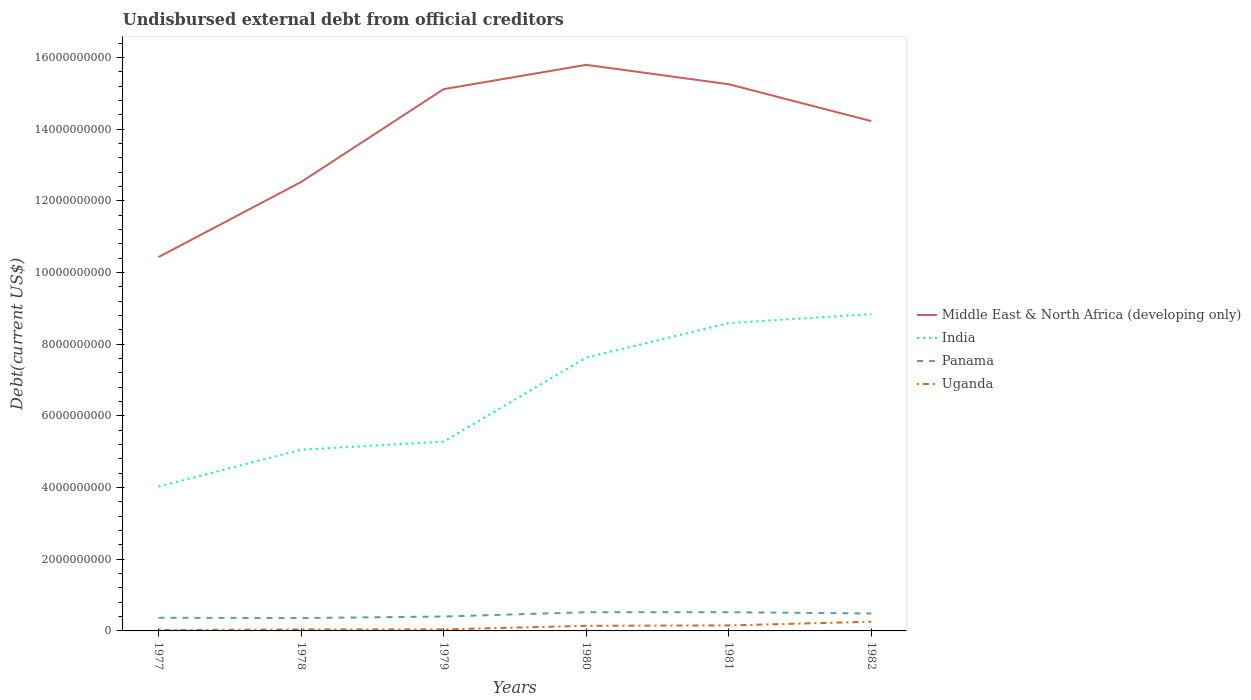Is the number of lines equal to the number of legend labels?
Keep it short and to the point. Yes. Across all years, what is the maximum total debt in Middle East & North Africa (developing only)?
Keep it short and to the point. 1.04e+1. What is the total total debt in Uganda in the graph?
Provide a succinct answer. -1.64e+07. What is the difference between the highest and the second highest total debt in India?
Make the answer very short. 4.81e+09. Is the total debt in Panama strictly greater than the total debt in Uganda over the years?
Provide a succinct answer. No. Does the graph contain any zero values?
Provide a succinct answer. No. Does the graph contain grids?
Your response must be concise. No. Where does the legend appear in the graph?
Ensure brevity in your answer.  Center right. What is the title of the graph?
Keep it short and to the point. Undisbursed external debt from official creditors. Does "Denmark" appear as one of the legend labels in the graph?
Offer a very short reply. No. What is the label or title of the Y-axis?
Keep it short and to the point. Debt(current US$). What is the Debt(current US$) of Middle East & North Africa (developing only) in 1977?
Keep it short and to the point. 1.04e+1. What is the Debt(current US$) in India in 1977?
Make the answer very short. 4.03e+09. What is the Debt(current US$) in Panama in 1977?
Your answer should be very brief. 3.67e+08. What is the Debt(current US$) in Uganda in 1977?
Keep it short and to the point. 2.43e+07. What is the Debt(current US$) in Middle East & North Africa (developing only) in 1978?
Your response must be concise. 1.25e+1. What is the Debt(current US$) of India in 1978?
Keep it short and to the point. 5.06e+09. What is the Debt(current US$) of Panama in 1978?
Make the answer very short. 3.59e+08. What is the Debt(current US$) in Uganda in 1978?
Provide a succinct answer. 4.07e+07. What is the Debt(current US$) of Middle East & North Africa (developing only) in 1979?
Offer a terse response. 1.51e+1. What is the Debt(current US$) in India in 1979?
Make the answer very short. 5.28e+09. What is the Debt(current US$) in Panama in 1979?
Keep it short and to the point. 4.02e+08. What is the Debt(current US$) of Uganda in 1979?
Offer a very short reply. 4.16e+07. What is the Debt(current US$) of Middle East & North Africa (developing only) in 1980?
Provide a short and direct response. 1.58e+1. What is the Debt(current US$) in India in 1980?
Ensure brevity in your answer.  7.63e+09. What is the Debt(current US$) in Panama in 1980?
Ensure brevity in your answer.  5.22e+08. What is the Debt(current US$) of Uganda in 1980?
Keep it short and to the point. 1.43e+08. What is the Debt(current US$) of Middle East & North Africa (developing only) in 1981?
Give a very brief answer. 1.53e+1. What is the Debt(current US$) in India in 1981?
Ensure brevity in your answer.  8.59e+09. What is the Debt(current US$) of Panama in 1981?
Provide a succinct answer. 5.22e+08. What is the Debt(current US$) in Uganda in 1981?
Offer a very short reply. 1.53e+08. What is the Debt(current US$) of Middle East & North Africa (developing only) in 1982?
Your answer should be very brief. 1.42e+1. What is the Debt(current US$) of India in 1982?
Keep it short and to the point. 8.84e+09. What is the Debt(current US$) in Panama in 1982?
Your response must be concise. 4.87e+08. What is the Debt(current US$) in Uganda in 1982?
Keep it short and to the point. 2.56e+08. Across all years, what is the maximum Debt(current US$) of Middle East & North Africa (developing only)?
Provide a short and direct response. 1.58e+1. Across all years, what is the maximum Debt(current US$) of India?
Offer a very short reply. 8.84e+09. Across all years, what is the maximum Debt(current US$) in Panama?
Keep it short and to the point. 5.22e+08. Across all years, what is the maximum Debt(current US$) in Uganda?
Your answer should be compact. 2.56e+08. Across all years, what is the minimum Debt(current US$) of Middle East & North Africa (developing only)?
Provide a succinct answer. 1.04e+1. Across all years, what is the minimum Debt(current US$) of India?
Provide a short and direct response. 4.03e+09. Across all years, what is the minimum Debt(current US$) in Panama?
Your answer should be very brief. 3.59e+08. Across all years, what is the minimum Debt(current US$) of Uganda?
Provide a succinct answer. 2.43e+07. What is the total Debt(current US$) of Middle East & North Africa (developing only) in the graph?
Your answer should be very brief. 8.34e+1. What is the total Debt(current US$) in India in the graph?
Provide a short and direct response. 3.94e+1. What is the total Debt(current US$) in Panama in the graph?
Ensure brevity in your answer.  2.66e+09. What is the total Debt(current US$) in Uganda in the graph?
Provide a short and direct response. 6.59e+08. What is the difference between the Debt(current US$) of Middle East & North Africa (developing only) in 1977 and that in 1978?
Provide a succinct answer. -2.10e+09. What is the difference between the Debt(current US$) in India in 1977 and that in 1978?
Provide a succinct answer. -1.03e+09. What is the difference between the Debt(current US$) of Panama in 1977 and that in 1978?
Offer a terse response. 8.48e+06. What is the difference between the Debt(current US$) of Uganda in 1977 and that in 1978?
Your answer should be compact. -1.64e+07. What is the difference between the Debt(current US$) in Middle East & North Africa (developing only) in 1977 and that in 1979?
Make the answer very short. -4.69e+09. What is the difference between the Debt(current US$) in India in 1977 and that in 1979?
Give a very brief answer. -1.25e+09. What is the difference between the Debt(current US$) in Panama in 1977 and that in 1979?
Your response must be concise. -3.46e+07. What is the difference between the Debt(current US$) in Uganda in 1977 and that in 1979?
Offer a terse response. -1.73e+07. What is the difference between the Debt(current US$) in Middle East & North Africa (developing only) in 1977 and that in 1980?
Provide a short and direct response. -5.37e+09. What is the difference between the Debt(current US$) of India in 1977 and that in 1980?
Provide a short and direct response. -3.60e+09. What is the difference between the Debt(current US$) in Panama in 1977 and that in 1980?
Make the answer very short. -1.54e+08. What is the difference between the Debt(current US$) of Uganda in 1977 and that in 1980?
Your response must be concise. -1.18e+08. What is the difference between the Debt(current US$) of Middle East & North Africa (developing only) in 1977 and that in 1981?
Ensure brevity in your answer.  -4.82e+09. What is the difference between the Debt(current US$) in India in 1977 and that in 1981?
Give a very brief answer. -4.56e+09. What is the difference between the Debt(current US$) in Panama in 1977 and that in 1981?
Your response must be concise. -1.55e+08. What is the difference between the Debt(current US$) of Uganda in 1977 and that in 1981?
Keep it short and to the point. -1.29e+08. What is the difference between the Debt(current US$) in Middle East & North Africa (developing only) in 1977 and that in 1982?
Ensure brevity in your answer.  -3.80e+09. What is the difference between the Debt(current US$) in India in 1977 and that in 1982?
Make the answer very short. -4.81e+09. What is the difference between the Debt(current US$) in Panama in 1977 and that in 1982?
Provide a succinct answer. -1.20e+08. What is the difference between the Debt(current US$) in Uganda in 1977 and that in 1982?
Give a very brief answer. -2.32e+08. What is the difference between the Debt(current US$) of Middle East & North Africa (developing only) in 1978 and that in 1979?
Offer a terse response. -2.59e+09. What is the difference between the Debt(current US$) in India in 1978 and that in 1979?
Give a very brief answer. -2.26e+08. What is the difference between the Debt(current US$) of Panama in 1978 and that in 1979?
Ensure brevity in your answer.  -4.30e+07. What is the difference between the Debt(current US$) of Uganda in 1978 and that in 1979?
Give a very brief answer. -9.00e+05. What is the difference between the Debt(current US$) of Middle East & North Africa (developing only) in 1978 and that in 1980?
Offer a terse response. -3.27e+09. What is the difference between the Debt(current US$) in India in 1978 and that in 1980?
Make the answer very short. -2.57e+09. What is the difference between the Debt(current US$) in Panama in 1978 and that in 1980?
Ensure brevity in your answer.  -1.63e+08. What is the difference between the Debt(current US$) of Uganda in 1978 and that in 1980?
Offer a terse response. -1.02e+08. What is the difference between the Debt(current US$) of Middle East & North Africa (developing only) in 1978 and that in 1981?
Provide a succinct answer. -2.73e+09. What is the difference between the Debt(current US$) of India in 1978 and that in 1981?
Make the answer very short. -3.53e+09. What is the difference between the Debt(current US$) of Panama in 1978 and that in 1981?
Provide a short and direct response. -1.63e+08. What is the difference between the Debt(current US$) in Uganda in 1978 and that in 1981?
Keep it short and to the point. -1.13e+08. What is the difference between the Debt(current US$) in Middle East & North Africa (developing only) in 1978 and that in 1982?
Your answer should be compact. -1.70e+09. What is the difference between the Debt(current US$) of India in 1978 and that in 1982?
Keep it short and to the point. -3.78e+09. What is the difference between the Debt(current US$) in Panama in 1978 and that in 1982?
Your answer should be very brief. -1.28e+08. What is the difference between the Debt(current US$) in Uganda in 1978 and that in 1982?
Offer a terse response. -2.16e+08. What is the difference between the Debt(current US$) of Middle East & North Africa (developing only) in 1979 and that in 1980?
Ensure brevity in your answer.  -6.79e+08. What is the difference between the Debt(current US$) in India in 1979 and that in 1980?
Your answer should be very brief. -2.35e+09. What is the difference between the Debt(current US$) of Panama in 1979 and that in 1980?
Provide a short and direct response. -1.20e+08. What is the difference between the Debt(current US$) of Uganda in 1979 and that in 1980?
Provide a succinct answer. -1.01e+08. What is the difference between the Debt(current US$) in Middle East & North Africa (developing only) in 1979 and that in 1981?
Make the answer very short. -1.38e+08. What is the difference between the Debt(current US$) in India in 1979 and that in 1981?
Offer a terse response. -3.31e+09. What is the difference between the Debt(current US$) of Panama in 1979 and that in 1981?
Give a very brief answer. -1.20e+08. What is the difference between the Debt(current US$) in Uganda in 1979 and that in 1981?
Give a very brief answer. -1.12e+08. What is the difference between the Debt(current US$) in Middle East & North Africa (developing only) in 1979 and that in 1982?
Your response must be concise. 8.91e+08. What is the difference between the Debt(current US$) of India in 1979 and that in 1982?
Your answer should be compact. -3.56e+09. What is the difference between the Debt(current US$) of Panama in 1979 and that in 1982?
Give a very brief answer. -8.52e+07. What is the difference between the Debt(current US$) in Uganda in 1979 and that in 1982?
Provide a succinct answer. -2.15e+08. What is the difference between the Debt(current US$) in Middle East & North Africa (developing only) in 1980 and that in 1981?
Your answer should be compact. 5.41e+08. What is the difference between the Debt(current US$) of India in 1980 and that in 1981?
Ensure brevity in your answer.  -9.64e+08. What is the difference between the Debt(current US$) in Panama in 1980 and that in 1981?
Offer a terse response. -1.86e+05. What is the difference between the Debt(current US$) in Uganda in 1980 and that in 1981?
Your response must be concise. -1.08e+07. What is the difference between the Debt(current US$) of Middle East & North Africa (developing only) in 1980 and that in 1982?
Your answer should be compact. 1.57e+09. What is the difference between the Debt(current US$) of India in 1980 and that in 1982?
Ensure brevity in your answer.  -1.21e+09. What is the difference between the Debt(current US$) in Panama in 1980 and that in 1982?
Offer a terse response. 3.46e+07. What is the difference between the Debt(current US$) of Uganda in 1980 and that in 1982?
Offer a terse response. -1.14e+08. What is the difference between the Debt(current US$) in Middle East & North Africa (developing only) in 1981 and that in 1982?
Your answer should be very brief. 1.03e+09. What is the difference between the Debt(current US$) in India in 1981 and that in 1982?
Give a very brief answer. -2.50e+08. What is the difference between the Debt(current US$) of Panama in 1981 and that in 1982?
Make the answer very short. 3.48e+07. What is the difference between the Debt(current US$) of Uganda in 1981 and that in 1982?
Keep it short and to the point. -1.03e+08. What is the difference between the Debt(current US$) in Middle East & North Africa (developing only) in 1977 and the Debt(current US$) in India in 1978?
Your answer should be compact. 5.38e+09. What is the difference between the Debt(current US$) of Middle East & North Africa (developing only) in 1977 and the Debt(current US$) of Panama in 1978?
Provide a succinct answer. 1.01e+1. What is the difference between the Debt(current US$) of Middle East & North Africa (developing only) in 1977 and the Debt(current US$) of Uganda in 1978?
Your answer should be compact. 1.04e+1. What is the difference between the Debt(current US$) of India in 1977 and the Debt(current US$) of Panama in 1978?
Your answer should be very brief. 3.67e+09. What is the difference between the Debt(current US$) in India in 1977 and the Debt(current US$) in Uganda in 1978?
Offer a terse response. 3.99e+09. What is the difference between the Debt(current US$) in Panama in 1977 and the Debt(current US$) in Uganda in 1978?
Offer a very short reply. 3.27e+08. What is the difference between the Debt(current US$) in Middle East & North Africa (developing only) in 1977 and the Debt(current US$) in India in 1979?
Provide a succinct answer. 5.15e+09. What is the difference between the Debt(current US$) in Middle East & North Africa (developing only) in 1977 and the Debt(current US$) in Panama in 1979?
Make the answer very short. 1.00e+1. What is the difference between the Debt(current US$) of Middle East & North Africa (developing only) in 1977 and the Debt(current US$) of Uganda in 1979?
Offer a very short reply. 1.04e+1. What is the difference between the Debt(current US$) in India in 1977 and the Debt(current US$) in Panama in 1979?
Your response must be concise. 3.63e+09. What is the difference between the Debt(current US$) in India in 1977 and the Debt(current US$) in Uganda in 1979?
Offer a terse response. 3.99e+09. What is the difference between the Debt(current US$) of Panama in 1977 and the Debt(current US$) of Uganda in 1979?
Offer a very short reply. 3.26e+08. What is the difference between the Debt(current US$) of Middle East & North Africa (developing only) in 1977 and the Debt(current US$) of India in 1980?
Offer a very short reply. 2.80e+09. What is the difference between the Debt(current US$) in Middle East & North Africa (developing only) in 1977 and the Debt(current US$) in Panama in 1980?
Give a very brief answer. 9.91e+09. What is the difference between the Debt(current US$) of Middle East & North Africa (developing only) in 1977 and the Debt(current US$) of Uganda in 1980?
Make the answer very short. 1.03e+1. What is the difference between the Debt(current US$) in India in 1977 and the Debt(current US$) in Panama in 1980?
Give a very brief answer. 3.51e+09. What is the difference between the Debt(current US$) of India in 1977 and the Debt(current US$) of Uganda in 1980?
Ensure brevity in your answer.  3.89e+09. What is the difference between the Debt(current US$) of Panama in 1977 and the Debt(current US$) of Uganda in 1980?
Make the answer very short. 2.25e+08. What is the difference between the Debt(current US$) of Middle East & North Africa (developing only) in 1977 and the Debt(current US$) of India in 1981?
Offer a terse response. 1.84e+09. What is the difference between the Debt(current US$) of Middle East & North Africa (developing only) in 1977 and the Debt(current US$) of Panama in 1981?
Your response must be concise. 9.91e+09. What is the difference between the Debt(current US$) of Middle East & North Africa (developing only) in 1977 and the Debt(current US$) of Uganda in 1981?
Provide a short and direct response. 1.03e+1. What is the difference between the Debt(current US$) in India in 1977 and the Debt(current US$) in Panama in 1981?
Ensure brevity in your answer.  3.51e+09. What is the difference between the Debt(current US$) of India in 1977 and the Debt(current US$) of Uganda in 1981?
Provide a short and direct response. 3.88e+09. What is the difference between the Debt(current US$) of Panama in 1977 and the Debt(current US$) of Uganda in 1981?
Keep it short and to the point. 2.14e+08. What is the difference between the Debt(current US$) in Middle East & North Africa (developing only) in 1977 and the Debt(current US$) in India in 1982?
Keep it short and to the point. 1.59e+09. What is the difference between the Debt(current US$) of Middle East & North Africa (developing only) in 1977 and the Debt(current US$) of Panama in 1982?
Provide a succinct answer. 9.95e+09. What is the difference between the Debt(current US$) of Middle East & North Africa (developing only) in 1977 and the Debt(current US$) of Uganda in 1982?
Your answer should be very brief. 1.02e+1. What is the difference between the Debt(current US$) in India in 1977 and the Debt(current US$) in Panama in 1982?
Ensure brevity in your answer.  3.54e+09. What is the difference between the Debt(current US$) of India in 1977 and the Debt(current US$) of Uganda in 1982?
Offer a very short reply. 3.77e+09. What is the difference between the Debt(current US$) in Panama in 1977 and the Debt(current US$) in Uganda in 1982?
Provide a succinct answer. 1.11e+08. What is the difference between the Debt(current US$) in Middle East & North Africa (developing only) in 1978 and the Debt(current US$) in India in 1979?
Provide a short and direct response. 7.25e+09. What is the difference between the Debt(current US$) of Middle East & North Africa (developing only) in 1978 and the Debt(current US$) of Panama in 1979?
Give a very brief answer. 1.21e+1. What is the difference between the Debt(current US$) of Middle East & North Africa (developing only) in 1978 and the Debt(current US$) of Uganda in 1979?
Your answer should be very brief. 1.25e+1. What is the difference between the Debt(current US$) in India in 1978 and the Debt(current US$) in Panama in 1979?
Provide a succinct answer. 4.66e+09. What is the difference between the Debt(current US$) in India in 1978 and the Debt(current US$) in Uganda in 1979?
Offer a terse response. 5.02e+09. What is the difference between the Debt(current US$) in Panama in 1978 and the Debt(current US$) in Uganda in 1979?
Make the answer very short. 3.17e+08. What is the difference between the Debt(current US$) in Middle East & North Africa (developing only) in 1978 and the Debt(current US$) in India in 1980?
Offer a very short reply. 4.90e+09. What is the difference between the Debt(current US$) in Middle East & North Africa (developing only) in 1978 and the Debt(current US$) in Panama in 1980?
Ensure brevity in your answer.  1.20e+1. What is the difference between the Debt(current US$) in Middle East & North Africa (developing only) in 1978 and the Debt(current US$) in Uganda in 1980?
Your answer should be compact. 1.24e+1. What is the difference between the Debt(current US$) in India in 1978 and the Debt(current US$) in Panama in 1980?
Your answer should be very brief. 4.54e+09. What is the difference between the Debt(current US$) in India in 1978 and the Debt(current US$) in Uganda in 1980?
Keep it short and to the point. 4.91e+09. What is the difference between the Debt(current US$) in Panama in 1978 and the Debt(current US$) in Uganda in 1980?
Offer a terse response. 2.16e+08. What is the difference between the Debt(current US$) of Middle East & North Africa (developing only) in 1978 and the Debt(current US$) of India in 1981?
Offer a very short reply. 3.94e+09. What is the difference between the Debt(current US$) in Middle East & North Africa (developing only) in 1978 and the Debt(current US$) in Panama in 1981?
Provide a short and direct response. 1.20e+1. What is the difference between the Debt(current US$) in Middle East & North Africa (developing only) in 1978 and the Debt(current US$) in Uganda in 1981?
Keep it short and to the point. 1.24e+1. What is the difference between the Debt(current US$) of India in 1978 and the Debt(current US$) of Panama in 1981?
Your answer should be compact. 4.54e+09. What is the difference between the Debt(current US$) of India in 1978 and the Debt(current US$) of Uganda in 1981?
Give a very brief answer. 4.90e+09. What is the difference between the Debt(current US$) of Panama in 1978 and the Debt(current US$) of Uganda in 1981?
Your answer should be very brief. 2.05e+08. What is the difference between the Debt(current US$) in Middle East & North Africa (developing only) in 1978 and the Debt(current US$) in India in 1982?
Offer a terse response. 3.69e+09. What is the difference between the Debt(current US$) in Middle East & North Africa (developing only) in 1978 and the Debt(current US$) in Panama in 1982?
Offer a very short reply. 1.20e+1. What is the difference between the Debt(current US$) of Middle East & North Africa (developing only) in 1978 and the Debt(current US$) of Uganda in 1982?
Keep it short and to the point. 1.23e+1. What is the difference between the Debt(current US$) of India in 1978 and the Debt(current US$) of Panama in 1982?
Your answer should be very brief. 4.57e+09. What is the difference between the Debt(current US$) in India in 1978 and the Debt(current US$) in Uganda in 1982?
Give a very brief answer. 4.80e+09. What is the difference between the Debt(current US$) in Panama in 1978 and the Debt(current US$) in Uganda in 1982?
Provide a succinct answer. 1.02e+08. What is the difference between the Debt(current US$) in Middle East & North Africa (developing only) in 1979 and the Debt(current US$) in India in 1980?
Keep it short and to the point. 7.49e+09. What is the difference between the Debt(current US$) of Middle East & North Africa (developing only) in 1979 and the Debt(current US$) of Panama in 1980?
Your answer should be very brief. 1.46e+1. What is the difference between the Debt(current US$) in Middle East & North Africa (developing only) in 1979 and the Debt(current US$) in Uganda in 1980?
Keep it short and to the point. 1.50e+1. What is the difference between the Debt(current US$) of India in 1979 and the Debt(current US$) of Panama in 1980?
Give a very brief answer. 4.76e+09. What is the difference between the Debt(current US$) of India in 1979 and the Debt(current US$) of Uganda in 1980?
Make the answer very short. 5.14e+09. What is the difference between the Debt(current US$) in Panama in 1979 and the Debt(current US$) in Uganda in 1980?
Your answer should be very brief. 2.59e+08. What is the difference between the Debt(current US$) of Middle East & North Africa (developing only) in 1979 and the Debt(current US$) of India in 1981?
Your response must be concise. 6.53e+09. What is the difference between the Debt(current US$) of Middle East & North Africa (developing only) in 1979 and the Debt(current US$) of Panama in 1981?
Your answer should be compact. 1.46e+1. What is the difference between the Debt(current US$) of Middle East & North Africa (developing only) in 1979 and the Debt(current US$) of Uganda in 1981?
Your answer should be very brief. 1.50e+1. What is the difference between the Debt(current US$) in India in 1979 and the Debt(current US$) in Panama in 1981?
Give a very brief answer. 4.76e+09. What is the difference between the Debt(current US$) in India in 1979 and the Debt(current US$) in Uganda in 1981?
Offer a very short reply. 5.13e+09. What is the difference between the Debt(current US$) in Panama in 1979 and the Debt(current US$) in Uganda in 1981?
Offer a very short reply. 2.48e+08. What is the difference between the Debt(current US$) of Middle East & North Africa (developing only) in 1979 and the Debt(current US$) of India in 1982?
Offer a very short reply. 6.28e+09. What is the difference between the Debt(current US$) of Middle East & North Africa (developing only) in 1979 and the Debt(current US$) of Panama in 1982?
Ensure brevity in your answer.  1.46e+1. What is the difference between the Debt(current US$) of Middle East & North Africa (developing only) in 1979 and the Debt(current US$) of Uganda in 1982?
Your response must be concise. 1.49e+1. What is the difference between the Debt(current US$) of India in 1979 and the Debt(current US$) of Panama in 1982?
Offer a terse response. 4.80e+09. What is the difference between the Debt(current US$) in India in 1979 and the Debt(current US$) in Uganda in 1982?
Provide a succinct answer. 5.03e+09. What is the difference between the Debt(current US$) in Panama in 1979 and the Debt(current US$) in Uganda in 1982?
Provide a short and direct response. 1.45e+08. What is the difference between the Debt(current US$) in Middle East & North Africa (developing only) in 1980 and the Debt(current US$) in India in 1981?
Ensure brevity in your answer.  7.21e+09. What is the difference between the Debt(current US$) in Middle East & North Africa (developing only) in 1980 and the Debt(current US$) in Panama in 1981?
Provide a short and direct response. 1.53e+1. What is the difference between the Debt(current US$) in Middle East & North Africa (developing only) in 1980 and the Debt(current US$) in Uganda in 1981?
Offer a very short reply. 1.56e+1. What is the difference between the Debt(current US$) of India in 1980 and the Debt(current US$) of Panama in 1981?
Provide a short and direct response. 7.11e+09. What is the difference between the Debt(current US$) of India in 1980 and the Debt(current US$) of Uganda in 1981?
Give a very brief answer. 7.48e+09. What is the difference between the Debt(current US$) of Panama in 1980 and the Debt(current US$) of Uganda in 1981?
Give a very brief answer. 3.68e+08. What is the difference between the Debt(current US$) in Middle East & North Africa (developing only) in 1980 and the Debt(current US$) in India in 1982?
Offer a very short reply. 6.96e+09. What is the difference between the Debt(current US$) of Middle East & North Africa (developing only) in 1980 and the Debt(current US$) of Panama in 1982?
Your answer should be compact. 1.53e+1. What is the difference between the Debt(current US$) in Middle East & North Africa (developing only) in 1980 and the Debt(current US$) in Uganda in 1982?
Offer a very short reply. 1.55e+1. What is the difference between the Debt(current US$) in India in 1980 and the Debt(current US$) in Panama in 1982?
Provide a succinct answer. 7.14e+09. What is the difference between the Debt(current US$) in India in 1980 and the Debt(current US$) in Uganda in 1982?
Keep it short and to the point. 7.37e+09. What is the difference between the Debt(current US$) in Panama in 1980 and the Debt(current US$) in Uganda in 1982?
Provide a short and direct response. 2.65e+08. What is the difference between the Debt(current US$) in Middle East & North Africa (developing only) in 1981 and the Debt(current US$) in India in 1982?
Your response must be concise. 6.42e+09. What is the difference between the Debt(current US$) in Middle East & North Africa (developing only) in 1981 and the Debt(current US$) in Panama in 1982?
Make the answer very short. 1.48e+1. What is the difference between the Debt(current US$) of Middle East & North Africa (developing only) in 1981 and the Debt(current US$) of Uganda in 1982?
Offer a very short reply. 1.50e+1. What is the difference between the Debt(current US$) of India in 1981 and the Debt(current US$) of Panama in 1982?
Offer a very short reply. 8.11e+09. What is the difference between the Debt(current US$) of India in 1981 and the Debt(current US$) of Uganda in 1982?
Offer a very short reply. 8.34e+09. What is the difference between the Debt(current US$) in Panama in 1981 and the Debt(current US$) in Uganda in 1982?
Provide a succinct answer. 2.65e+08. What is the average Debt(current US$) in Middle East & North Africa (developing only) per year?
Your answer should be very brief. 1.39e+1. What is the average Debt(current US$) in India per year?
Ensure brevity in your answer.  6.57e+09. What is the average Debt(current US$) in Panama per year?
Provide a short and direct response. 4.43e+08. What is the average Debt(current US$) in Uganda per year?
Ensure brevity in your answer.  1.10e+08. In the year 1977, what is the difference between the Debt(current US$) of Middle East & North Africa (developing only) and Debt(current US$) of India?
Provide a succinct answer. 6.40e+09. In the year 1977, what is the difference between the Debt(current US$) in Middle East & North Africa (developing only) and Debt(current US$) in Panama?
Provide a succinct answer. 1.01e+1. In the year 1977, what is the difference between the Debt(current US$) in Middle East & North Africa (developing only) and Debt(current US$) in Uganda?
Ensure brevity in your answer.  1.04e+1. In the year 1977, what is the difference between the Debt(current US$) in India and Debt(current US$) in Panama?
Offer a terse response. 3.66e+09. In the year 1977, what is the difference between the Debt(current US$) of India and Debt(current US$) of Uganda?
Your answer should be compact. 4.00e+09. In the year 1977, what is the difference between the Debt(current US$) in Panama and Debt(current US$) in Uganda?
Provide a short and direct response. 3.43e+08. In the year 1978, what is the difference between the Debt(current US$) of Middle East & North Africa (developing only) and Debt(current US$) of India?
Your answer should be compact. 7.47e+09. In the year 1978, what is the difference between the Debt(current US$) of Middle East & North Africa (developing only) and Debt(current US$) of Panama?
Provide a succinct answer. 1.22e+1. In the year 1978, what is the difference between the Debt(current US$) of Middle East & North Africa (developing only) and Debt(current US$) of Uganda?
Your answer should be very brief. 1.25e+1. In the year 1978, what is the difference between the Debt(current US$) of India and Debt(current US$) of Panama?
Offer a very short reply. 4.70e+09. In the year 1978, what is the difference between the Debt(current US$) in India and Debt(current US$) in Uganda?
Your answer should be compact. 5.02e+09. In the year 1978, what is the difference between the Debt(current US$) in Panama and Debt(current US$) in Uganda?
Make the answer very short. 3.18e+08. In the year 1979, what is the difference between the Debt(current US$) of Middle East & North Africa (developing only) and Debt(current US$) of India?
Make the answer very short. 9.84e+09. In the year 1979, what is the difference between the Debt(current US$) in Middle East & North Africa (developing only) and Debt(current US$) in Panama?
Your answer should be compact. 1.47e+1. In the year 1979, what is the difference between the Debt(current US$) in Middle East & North Africa (developing only) and Debt(current US$) in Uganda?
Provide a short and direct response. 1.51e+1. In the year 1979, what is the difference between the Debt(current US$) in India and Debt(current US$) in Panama?
Offer a terse response. 4.88e+09. In the year 1979, what is the difference between the Debt(current US$) in India and Debt(current US$) in Uganda?
Your answer should be very brief. 5.24e+09. In the year 1979, what is the difference between the Debt(current US$) of Panama and Debt(current US$) of Uganda?
Your answer should be very brief. 3.60e+08. In the year 1980, what is the difference between the Debt(current US$) in Middle East & North Africa (developing only) and Debt(current US$) in India?
Your response must be concise. 8.17e+09. In the year 1980, what is the difference between the Debt(current US$) in Middle East & North Africa (developing only) and Debt(current US$) in Panama?
Provide a short and direct response. 1.53e+1. In the year 1980, what is the difference between the Debt(current US$) of Middle East & North Africa (developing only) and Debt(current US$) of Uganda?
Offer a terse response. 1.57e+1. In the year 1980, what is the difference between the Debt(current US$) in India and Debt(current US$) in Panama?
Your answer should be compact. 7.11e+09. In the year 1980, what is the difference between the Debt(current US$) of India and Debt(current US$) of Uganda?
Keep it short and to the point. 7.49e+09. In the year 1980, what is the difference between the Debt(current US$) of Panama and Debt(current US$) of Uganda?
Give a very brief answer. 3.79e+08. In the year 1981, what is the difference between the Debt(current US$) in Middle East & North Africa (developing only) and Debt(current US$) in India?
Give a very brief answer. 6.67e+09. In the year 1981, what is the difference between the Debt(current US$) in Middle East & North Africa (developing only) and Debt(current US$) in Panama?
Make the answer very short. 1.47e+1. In the year 1981, what is the difference between the Debt(current US$) in Middle East & North Africa (developing only) and Debt(current US$) in Uganda?
Offer a very short reply. 1.51e+1. In the year 1981, what is the difference between the Debt(current US$) in India and Debt(current US$) in Panama?
Give a very brief answer. 8.07e+09. In the year 1981, what is the difference between the Debt(current US$) of India and Debt(current US$) of Uganda?
Your answer should be very brief. 8.44e+09. In the year 1981, what is the difference between the Debt(current US$) of Panama and Debt(current US$) of Uganda?
Provide a succinct answer. 3.68e+08. In the year 1982, what is the difference between the Debt(current US$) of Middle East & North Africa (developing only) and Debt(current US$) of India?
Keep it short and to the point. 5.39e+09. In the year 1982, what is the difference between the Debt(current US$) in Middle East & North Africa (developing only) and Debt(current US$) in Panama?
Your response must be concise. 1.37e+1. In the year 1982, what is the difference between the Debt(current US$) of Middle East & North Africa (developing only) and Debt(current US$) of Uganda?
Give a very brief answer. 1.40e+1. In the year 1982, what is the difference between the Debt(current US$) of India and Debt(current US$) of Panama?
Your answer should be compact. 8.36e+09. In the year 1982, what is the difference between the Debt(current US$) of India and Debt(current US$) of Uganda?
Offer a very short reply. 8.59e+09. In the year 1982, what is the difference between the Debt(current US$) of Panama and Debt(current US$) of Uganda?
Your answer should be very brief. 2.31e+08. What is the ratio of the Debt(current US$) in Middle East & North Africa (developing only) in 1977 to that in 1978?
Offer a terse response. 0.83. What is the ratio of the Debt(current US$) of India in 1977 to that in 1978?
Your answer should be very brief. 0.8. What is the ratio of the Debt(current US$) of Panama in 1977 to that in 1978?
Provide a succinct answer. 1.02. What is the ratio of the Debt(current US$) of Uganda in 1977 to that in 1978?
Provide a short and direct response. 0.6. What is the ratio of the Debt(current US$) in Middle East & North Africa (developing only) in 1977 to that in 1979?
Give a very brief answer. 0.69. What is the ratio of the Debt(current US$) of India in 1977 to that in 1979?
Give a very brief answer. 0.76. What is the ratio of the Debt(current US$) of Panama in 1977 to that in 1979?
Make the answer very short. 0.91. What is the ratio of the Debt(current US$) in Uganda in 1977 to that in 1979?
Offer a terse response. 0.58. What is the ratio of the Debt(current US$) in Middle East & North Africa (developing only) in 1977 to that in 1980?
Your response must be concise. 0.66. What is the ratio of the Debt(current US$) in India in 1977 to that in 1980?
Keep it short and to the point. 0.53. What is the ratio of the Debt(current US$) in Panama in 1977 to that in 1980?
Give a very brief answer. 0.7. What is the ratio of the Debt(current US$) of Uganda in 1977 to that in 1980?
Provide a short and direct response. 0.17. What is the ratio of the Debt(current US$) of Middle East & North Africa (developing only) in 1977 to that in 1981?
Provide a short and direct response. 0.68. What is the ratio of the Debt(current US$) of India in 1977 to that in 1981?
Keep it short and to the point. 0.47. What is the ratio of the Debt(current US$) in Panama in 1977 to that in 1981?
Provide a succinct answer. 0.7. What is the ratio of the Debt(current US$) in Uganda in 1977 to that in 1981?
Give a very brief answer. 0.16. What is the ratio of the Debt(current US$) of Middle East & North Africa (developing only) in 1977 to that in 1982?
Keep it short and to the point. 0.73. What is the ratio of the Debt(current US$) in India in 1977 to that in 1982?
Your response must be concise. 0.46. What is the ratio of the Debt(current US$) in Panama in 1977 to that in 1982?
Offer a terse response. 0.75. What is the ratio of the Debt(current US$) in Uganda in 1977 to that in 1982?
Provide a short and direct response. 0.09. What is the ratio of the Debt(current US$) of Middle East & North Africa (developing only) in 1978 to that in 1979?
Provide a short and direct response. 0.83. What is the ratio of the Debt(current US$) of India in 1978 to that in 1979?
Your response must be concise. 0.96. What is the ratio of the Debt(current US$) of Panama in 1978 to that in 1979?
Make the answer very short. 0.89. What is the ratio of the Debt(current US$) of Uganda in 1978 to that in 1979?
Provide a short and direct response. 0.98. What is the ratio of the Debt(current US$) in Middle East & North Africa (developing only) in 1978 to that in 1980?
Make the answer very short. 0.79. What is the ratio of the Debt(current US$) of India in 1978 to that in 1980?
Keep it short and to the point. 0.66. What is the ratio of the Debt(current US$) of Panama in 1978 to that in 1980?
Offer a very short reply. 0.69. What is the ratio of the Debt(current US$) in Uganda in 1978 to that in 1980?
Offer a terse response. 0.29. What is the ratio of the Debt(current US$) in Middle East & North Africa (developing only) in 1978 to that in 1981?
Offer a very short reply. 0.82. What is the ratio of the Debt(current US$) in India in 1978 to that in 1981?
Offer a very short reply. 0.59. What is the ratio of the Debt(current US$) in Panama in 1978 to that in 1981?
Ensure brevity in your answer.  0.69. What is the ratio of the Debt(current US$) in Uganda in 1978 to that in 1981?
Provide a short and direct response. 0.27. What is the ratio of the Debt(current US$) in Middle East & North Africa (developing only) in 1978 to that in 1982?
Make the answer very short. 0.88. What is the ratio of the Debt(current US$) of India in 1978 to that in 1982?
Give a very brief answer. 0.57. What is the ratio of the Debt(current US$) in Panama in 1978 to that in 1982?
Ensure brevity in your answer.  0.74. What is the ratio of the Debt(current US$) of Uganda in 1978 to that in 1982?
Offer a terse response. 0.16. What is the ratio of the Debt(current US$) in Middle East & North Africa (developing only) in 1979 to that in 1980?
Keep it short and to the point. 0.96. What is the ratio of the Debt(current US$) in India in 1979 to that in 1980?
Your answer should be very brief. 0.69. What is the ratio of the Debt(current US$) of Panama in 1979 to that in 1980?
Provide a succinct answer. 0.77. What is the ratio of the Debt(current US$) in Uganda in 1979 to that in 1980?
Make the answer very short. 0.29. What is the ratio of the Debt(current US$) in India in 1979 to that in 1981?
Your response must be concise. 0.61. What is the ratio of the Debt(current US$) of Panama in 1979 to that in 1981?
Your response must be concise. 0.77. What is the ratio of the Debt(current US$) in Uganda in 1979 to that in 1981?
Offer a very short reply. 0.27. What is the ratio of the Debt(current US$) in Middle East & North Africa (developing only) in 1979 to that in 1982?
Provide a succinct answer. 1.06. What is the ratio of the Debt(current US$) of India in 1979 to that in 1982?
Provide a succinct answer. 0.6. What is the ratio of the Debt(current US$) in Panama in 1979 to that in 1982?
Provide a short and direct response. 0.82. What is the ratio of the Debt(current US$) in Uganda in 1979 to that in 1982?
Keep it short and to the point. 0.16. What is the ratio of the Debt(current US$) of Middle East & North Africa (developing only) in 1980 to that in 1981?
Give a very brief answer. 1.04. What is the ratio of the Debt(current US$) in India in 1980 to that in 1981?
Make the answer very short. 0.89. What is the ratio of the Debt(current US$) of Uganda in 1980 to that in 1981?
Your answer should be compact. 0.93. What is the ratio of the Debt(current US$) in Middle East & North Africa (developing only) in 1980 to that in 1982?
Make the answer very short. 1.11. What is the ratio of the Debt(current US$) in India in 1980 to that in 1982?
Your answer should be compact. 0.86. What is the ratio of the Debt(current US$) of Panama in 1980 to that in 1982?
Offer a very short reply. 1.07. What is the ratio of the Debt(current US$) of Uganda in 1980 to that in 1982?
Ensure brevity in your answer.  0.56. What is the ratio of the Debt(current US$) of Middle East & North Africa (developing only) in 1981 to that in 1982?
Offer a terse response. 1.07. What is the ratio of the Debt(current US$) in India in 1981 to that in 1982?
Offer a very short reply. 0.97. What is the ratio of the Debt(current US$) in Panama in 1981 to that in 1982?
Ensure brevity in your answer.  1.07. What is the ratio of the Debt(current US$) of Uganda in 1981 to that in 1982?
Make the answer very short. 0.6. What is the difference between the highest and the second highest Debt(current US$) of Middle East & North Africa (developing only)?
Offer a terse response. 5.41e+08. What is the difference between the highest and the second highest Debt(current US$) of India?
Your answer should be very brief. 2.50e+08. What is the difference between the highest and the second highest Debt(current US$) of Panama?
Your answer should be compact. 1.86e+05. What is the difference between the highest and the second highest Debt(current US$) in Uganda?
Provide a succinct answer. 1.03e+08. What is the difference between the highest and the lowest Debt(current US$) in Middle East & North Africa (developing only)?
Offer a terse response. 5.37e+09. What is the difference between the highest and the lowest Debt(current US$) of India?
Your answer should be very brief. 4.81e+09. What is the difference between the highest and the lowest Debt(current US$) of Panama?
Your response must be concise. 1.63e+08. What is the difference between the highest and the lowest Debt(current US$) in Uganda?
Give a very brief answer. 2.32e+08. 